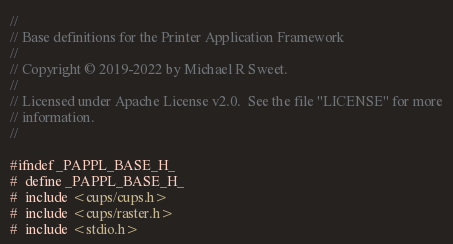<code> <loc_0><loc_0><loc_500><loc_500><_C_>//
// Base definitions for the Printer Application Framework
//
// Copyright © 2019-2022 by Michael R Sweet.
//
// Licensed under Apache License v2.0.  See the file "LICENSE" for more
// information.
//

#ifndef _PAPPL_BASE_H_
#  define _PAPPL_BASE_H_
#  include <cups/cups.h>
#  include <cups/raster.h>
#  include <stdio.h></code> 